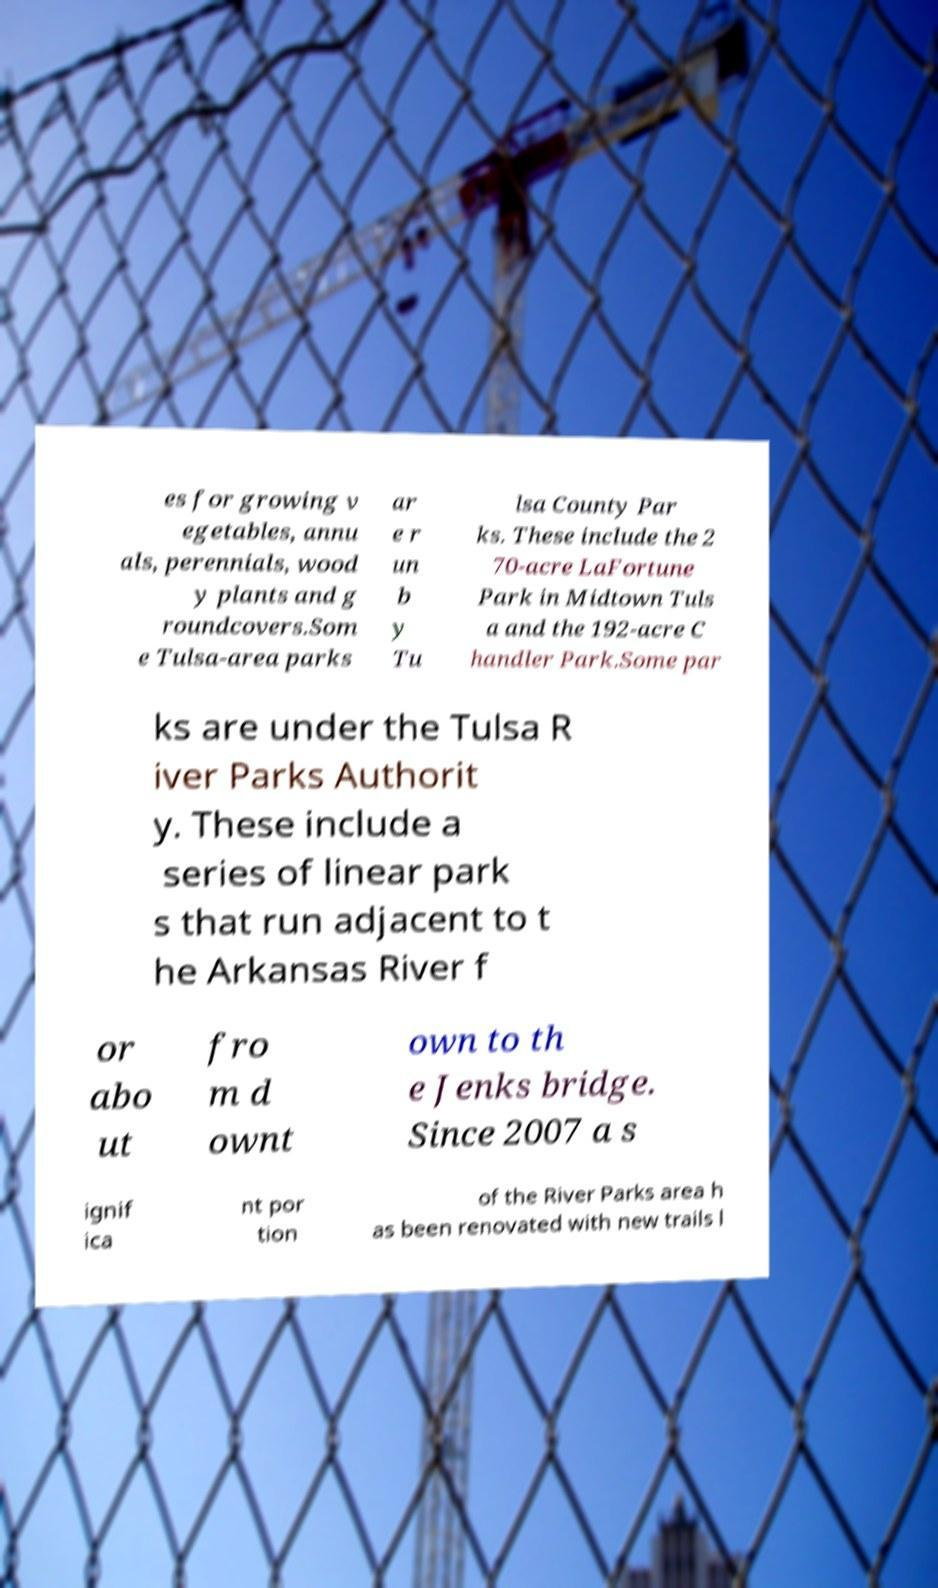Please read and relay the text visible in this image. What does it say? es for growing v egetables, annu als, perennials, wood y plants and g roundcovers.Som e Tulsa-area parks ar e r un b y Tu lsa County Par ks. These include the 2 70-acre LaFortune Park in Midtown Tuls a and the 192-acre C handler Park.Some par ks are under the Tulsa R iver Parks Authorit y. These include a series of linear park s that run adjacent to t he Arkansas River f or abo ut fro m d ownt own to th e Jenks bridge. Since 2007 a s ignif ica nt por tion of the River Parks area h as been renovated with new trails l 